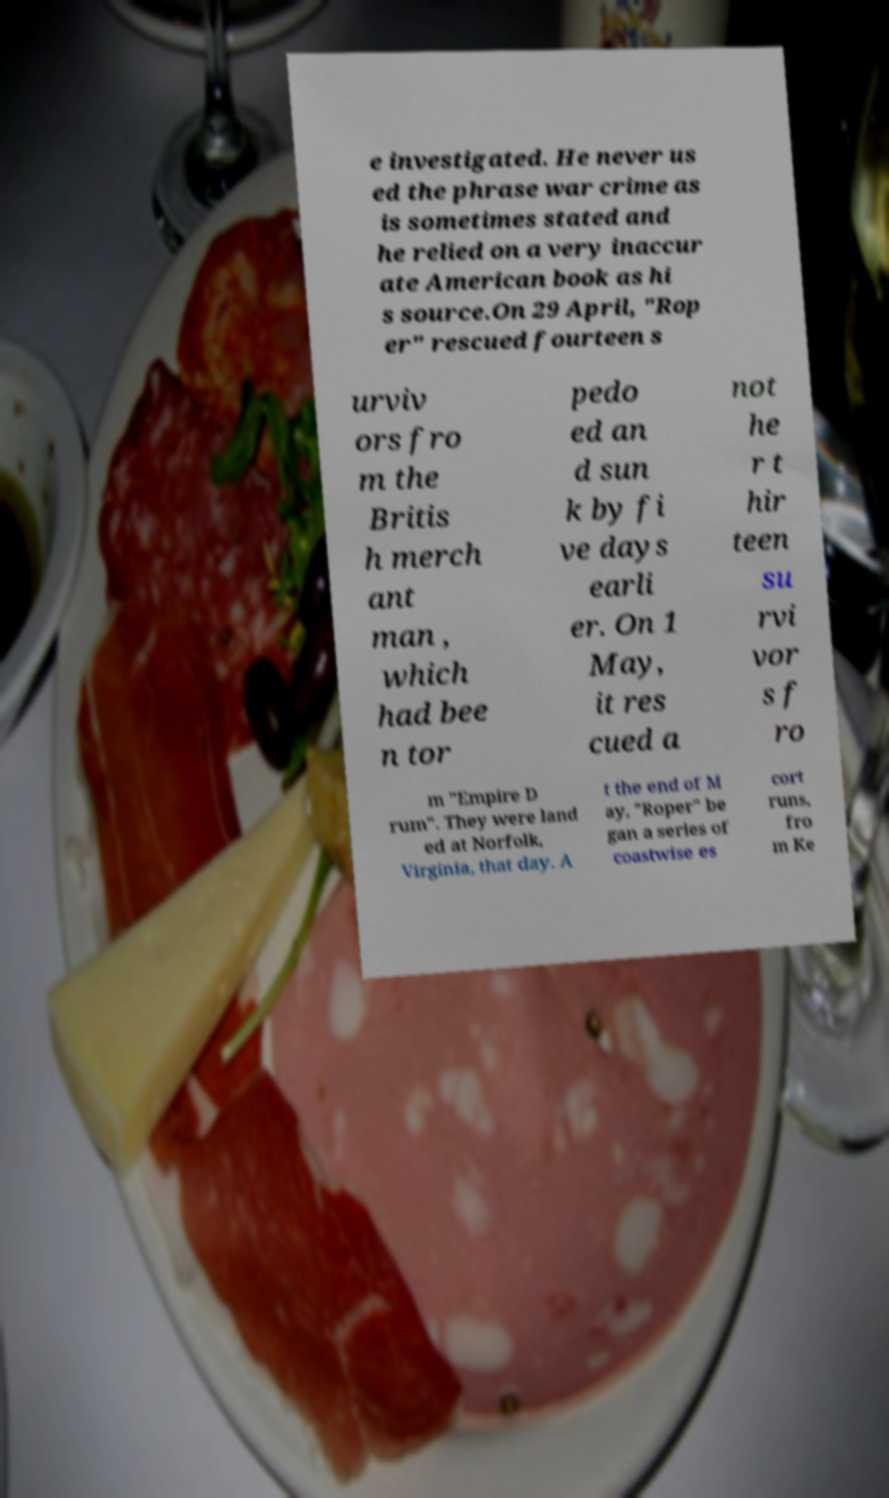Can you accurately transcribe the text from the provided image for me? e investigated. He never us ed the phrase war crime as is sometimes stated and he relied on a very inaccur ate American book as hi s source.On 29 April, "Rop er" rescued fourteen s urviv ors fro m the Britis h merch ant man , which had bee n tor pedo ed an d sun k by fi ve days earli er. On 1 May, it res cued a not he r t hir teen su rvi vor s f ro m "Empire D rum". They were land ed at Norfolk, Virginia, that day. A t the end of M ay, "Roper" be gan a series of coastwise es cort runs, fro m Ke 